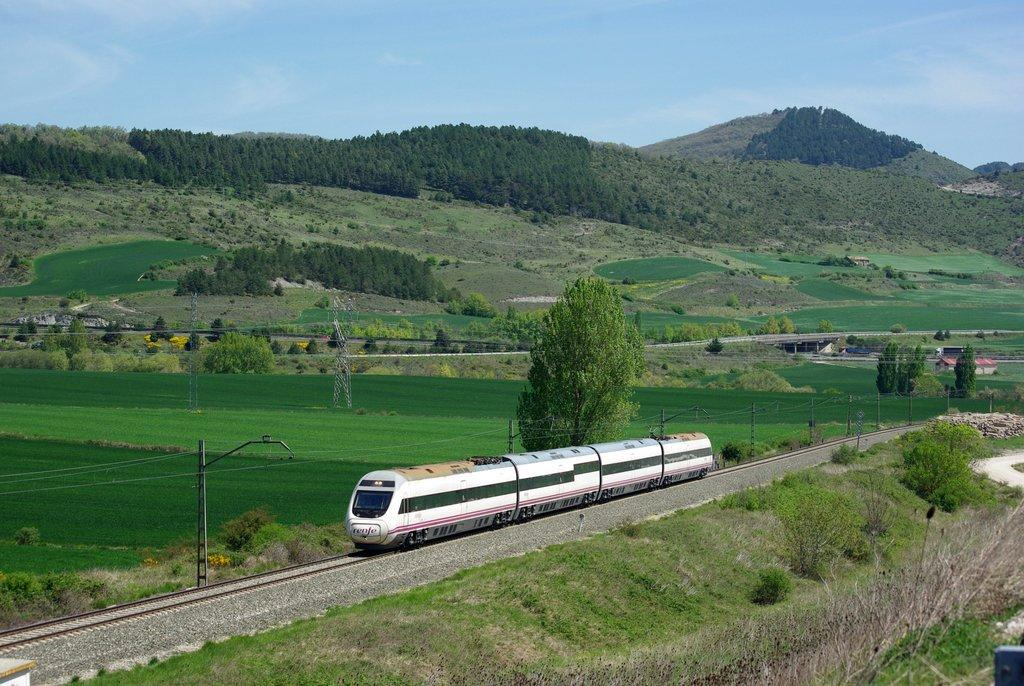What is the main subject of the image? The main subject of the image is a train. Can you describe the train in more detail? The train has wagons attached to it and is placed on a track. What can be seen in the background of the image? In the background of the image, there are poles, a group of trees, mountains, buildings, and the sky. How many kitties are playing with balls in the image? There are no kitties or balls present in the image. What type of flesh can be seen on the train in the image? There is no flesh visible on the train in the image; it is a mechanical object made of metal and other materials. 